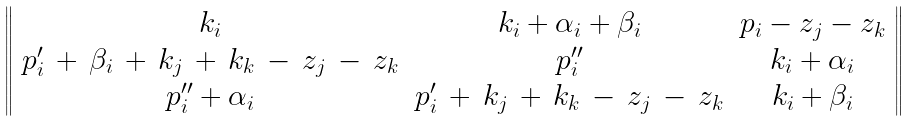<formula> <loc_0><loc_0><loc_500><loc_500>\left \| \begin{array} { c c c } k _ { i } & k _ { i } + \alpha _ { i } + \beta _ { i } & p _ { i } - z _ { j } - z _ { k } \\ p _ { i } ^ { \prime } \, + \, \beta _ { i } \, + \, k _ { j } \, + \, k _ { k } \, - \, z _ { j } \, - \, z _ { k } & p _ { i } ^ { \prime \prime } & k _ { i } + \alpha _ { i } \\ p _ { i } ^ { \prime \prime } + \alpha _ { i } & p _ { i } ^ { \prime } \, + \, k _ { j } \, + \, k _ { k } \, - \, z _ { j } \, - \, z _ { k } & k _ { i } + \beta _ { i } \end{array} \right \|</formula> 